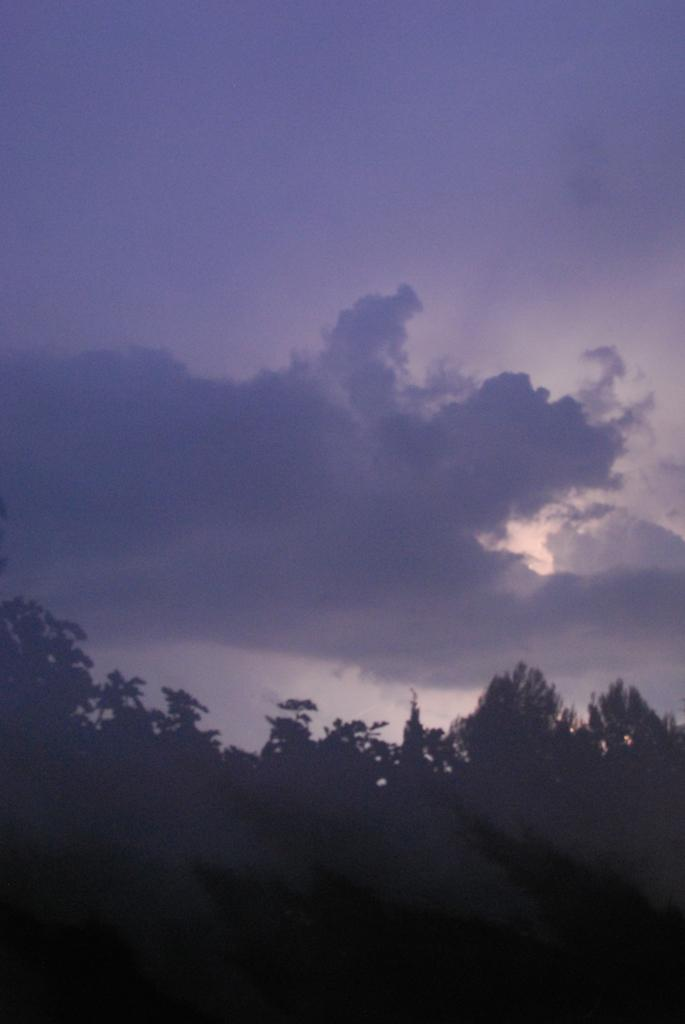What type of vegetation can be seen in the image? There are trees in the image. What is the condition of the sky in the image? The sky is cloudy in the image. What type of spy equipment can be seen in the image? There is no spy equipment present in the image; it features trees and a cloudy sky. How much money is visible in the image? There is no money visible in the image. 